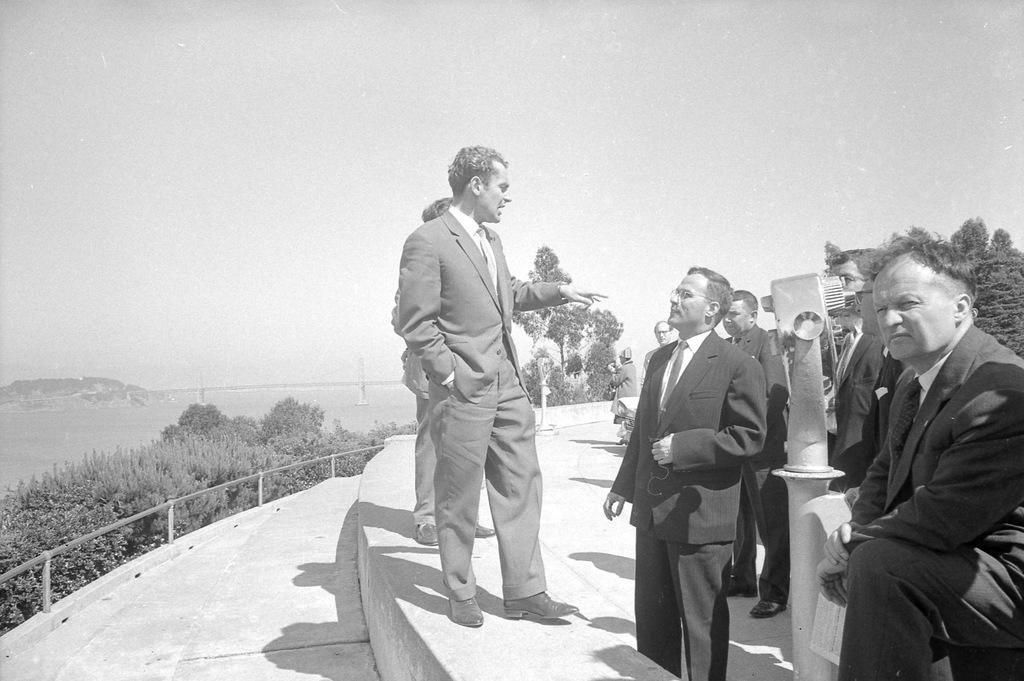What can be seen in the image? There are people standing in the image. What is on the right side of the image? There are trees on the right side of the image. What is visible at the top of the image? The sky is visible at the top of the image. What are the people in the front wearing? The people in the front are wearing suits. How many snails can be seen participating in the party in the image? There are no snails or party depicted in the image. What type of transport is being used by the people in the image? The image does not show any form of transport being used by the people. 